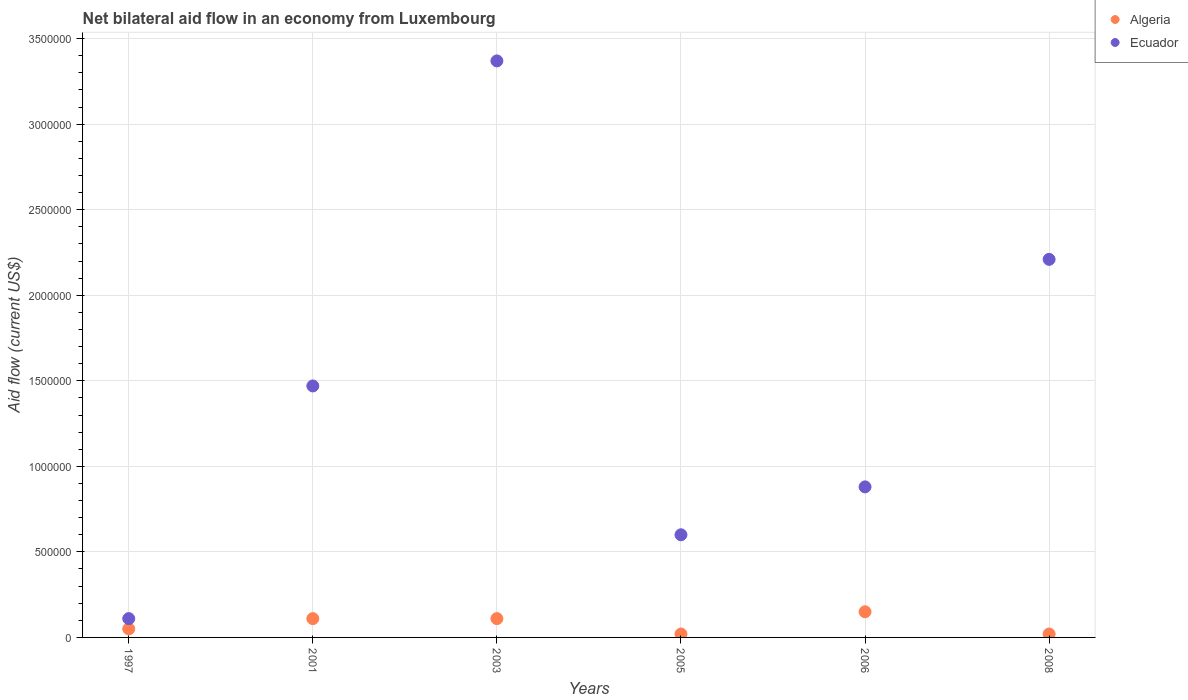How many different coloured dotlines are there?
Ensure brevity in your answer.  2. Across all years, what is the maximum net bilateral aid flow in Ecuador?
Your answer should be very brief. 3.37e+06. In which year was the net bilateral aid flow in Algeria maximum?
Make the answer very short. 2006. What is the total net bilateral aid flow in Algeria in the graph?
Offer a very short reply. 4.60e+05. What is the difference between the net bilateral aid flow in Algeria in 1997 and that in 2003?
Your response must be concise. -6.00e+04. What is the difference between the net bilateral aid flow in Ecuador in 2003 and the net bilateral aid flow in Algeria in 1997?
Offer a terse response. 3.32e+06. What is the average net bilateral aid flow in Ecuador per year?
Give a very brief answer. 1.44e+06. In the year 2005, what is the difference between the net bilateral aid flow in Ecuador and net bilateral aid flow in Algeria?
Make the answer very short. 5.80e+05. What is the ratio of the net bilateral aid flow in Algeria in 2003 to that in 2006?
Provide a short and direct response. 0.73. Is the net bilateral aid flow in Algeria in 2003 less than that in 2005?
Your answer should be very brief. No. Is the difference between the net bilateral aid flow in Ecuador in 2003 and 2005 greater than the difference between the net bilateral aid flow in Algeria in 2003 and 2005?
Give a very brief answer. Yes. What is the difference between the highest and the second highest net bilateral aid flow in Ecuador?
Make the answer very short. 1.16e+06. Is the sum of the net bilateral aid flow in Ecuador in 2003 and 2006 greater than the maximum net bilateral aid flow in Algeria across all years?
Give a very brief answer. Yes. Does the net bilateral aid flow in Algeria monotonically increase over the years?
Your answer should be very brief. No. Is the net bilateral aid flow in Algeria strictly greater than the net bilateral aid flow in Ecuador over the years?
Provide a short and direct response. No. Is the net bilateral aid flow in Ecuador strictly less than the net bilateral aid flow in Algeria over the years?
Your answer should be compact. No. How many years are there in the graph?
Your response must be concise. 6. How are the legend labels stacked?
Your answer should be compact. Vertical. What is the title of the graph?
Provide a succinct answer. Net bilateral aid flow in an economy from Luxembourg. What is the label or title of the Y-axis?
Your answer should be very brief. Aid flow (current US$). What is the Aid flow (current US$) of Ecuador in 1997?
Ensure brevity in your answer.  1.10e+05. What is the Aid flow (current US$) in Algeria in 2001?
Provide a short and direct response. 1.10e+05. What is the Aid flow (current US$) of Ecuador in 2001?
Keep it short and to the point. 1.47e+06. What is the Aid flow (current US$) of Ecuador in 2003?
Provide a succinct answer. 3.37e+06. What is the Aid flow (current US$) in Ecuador in 2005?
Your answer should be very brief. 6.00e+05. What is the Aid flow (current US$) of Ecuador in 2006?
Make the answer very short. 8.80e+05. What is the Aid flow (current US$) of Algeria in 2008?
Keep it short and to the point. 2.00e+04. What is the Aid flow (current US$) of Ecuador in 2008?
Keep it short and to the point. 2.21e+06. Across all years, what is the maximum Aid flow (current US$) of Ecuador?
Your answer should be very brief. 3.37e+06. Across all years, what is the minimum Aid flow (current US$) in Algeria?
Your answer should be compact. 2.00e+04. What is the total Aid flow (current US$) in Algeria in the graph?
Your answer should be very brief. 4.60e+05. What is the total Aid flow (current US$) in Ecuador in the graph?
Offer a very short reply. 8.64e+06. What is the difference between the Aid flow (current US$) in Algeria in 1997 and that in 2001?
Ensure brevity in your answer.  -6.00e+04. What is the difference between the Aid flow (current US$) of Ecuador in 1997 and that in 2001?
Your answer should be compact. -1.36e+06. What is the difference between the Aid flow (current US$) of Algeria in 1997 and that in 2003?
Give a very brief answer. -6.00e+04. What is the difference between the Aid flow (current US$) in Ecuador in 1997 and that in 2003?
Keep it short and to the point. -3.26e+06. What is the difference between the Aid flow (current US$) of Algeria in 1997 and that in 2005?
Your response must be concise. 3.00e+04. What is the difference between the Aid flow (current US$) in Ecuador in 1997 and that in 2005?
Keep it short and to the point. -4.90e+05. What is the difference between the Aid flow (current US$) of Algeria in 1997 and that in 2006?
Provide a short and direct response. -1.00e+05. What is the difference between the Aid flow (current US$) of Ecuador in 1997 and that in 2006?
Provide a succinct answer. -7.70e+05. What is the difference between the Aid flow (current US$) in Algeria in 1997 and that in 2008?
Ensure brevity in your answer.  3.00e+04. What is the difference between the Aid flow (current US$) of Ecuador in 1997 and that in 2008?
Your answer should be compact. -2.10e+06. What is the difference between the Aid flow (current US$) of Algeria in 2001 and that in 2003?
Your answer should be very brief. 0. What is the difference between the Aid flow (current US$) in Ecuador in 2001 and that in 2003?
Your response must be concise. -1.90e+06. What is the difference between the Aid flow (current US$) of Ecuador in 2001 and that in 2005?
Provide a short and direct response. 8.70e+05. What is the difference between the Aid flow (current US$) of Ecuador in 2001 and that in 2006?
Give a very brief answer. 5.90e+05. What is the difference between the Aid flow (current US$) of Ecuador in 2001 and that in 2008?
Provide a succinct answer. -7.40e+05. What is the difference between the Aid flow (current US$) of Ecuador in 2003 and that in 2005?
Offer a very short reply. 2.77e+06. What is the difference between the Aid flow (current US$) in Ecuador in 2003 and that in 2006?
Your answer should be very brief. 2.49e+06. What is the difference between the Aid flow (current US$) of Algeria in 2003 and that in 2008?
Your answer should be compact. 9.00e+04. What is the difference between the Aid flow (current US$) in Ecuador in 2003 and that in 2008?
Offer a very short reply. 1.16e+06. What is the difference between the Aid flow (current US$) in Algeria in 2005 and that in 2006?
Offer a terse response. -1.30e+05. What is the difference between the Aid flow (current US$) of Ecuador in 2005 and that in 2006?
Keep it short and to the point. -2.80e+05. What is the difference between the Aid flow (current US$) in Algeria in 2005 and that in 2008?
Your response must be concise. 0. What is the difference between the Aid flow (current US$) in Ecuador in 2005 and that in 2008?
Make the answer very short. -1.61e+06. What is the difference between the Aid flow (current US$) of Algeria in 2006 and that in 2008?
Your response must be concise. 1.30e+05. What is the difference between the Aid flow (current US$) in Ecuador in 2006 and that in 2008?
Your answer should be very brief. -1.33e+06. What is the difference between the Aid flow (current US$) in Algeria in 1997 and the Aid flow (current US$) in Ecuador in 2001?
Make the answer very short. -1.42e+06. What is the difference between the Aid flow (current US$) of Algeria in 1997 and the Aid flow (current US$) of Ecuador in 2003?
Offer a terse response. -3.32e+06. What is the difference between the Aid flow (current US$) in Algeria in 1997 and the Aid flow (current US$) in Ecuador in 2005?
Keep it short and to the point. -5.50e+05. What is the difference between the Aid flow (current US$) of Algeria in 1997 and the Aid flow (current US$) of Ecuador in 2006?
Offer a very short reply. -8.30e+05. What is the difference between the Aid flow (current US$) in Algeria in 1997 and the Aid flow (current US$) in Ecuador in 2008?
Provide a short and direct response. -2.16e+06. What is the difference between the Aid flow (current US$) of Algeria in 2001 and the Aid flow (current US$) of Ecuador in 2003?
Offer a terse response. -3.26e+06. What is the difference between the Aid flow (current US$) of Algeria in 2001 and the Aid flow (current US$) of Ecuador in 2005?
Offer a very short reply. -4.90e+05. What is the difference between the Aid flow (current US$) in Algeria in 2001 and the Aid flow (current US$) in Ecuador in 2006?
Give a very brief answer. -7.70e+05. What is the difference between the Aid flow (current US$) of Algeria in 2001 and the Aid flow (current US$) of Ecuador in 2008?
Your answer should be compact. -2.10e+06. What is the difference between the Aid flow (current US$) of Algeria in 2003 and the Aid flow (current US$) of Ecuador in 2005?
Your response must be concise. -4.90e+05. What is the difference between the Aid flow (current US$) in Algeria in 2003 and the Aid flow (current US$) in Ecuador in 2006?
Make the answer very short. -7.70e+05. What is the difference between the Aid flow (current US$) of Algeria in 2003 and the Aid flow (current US$) of Ecuador in 2008?
Ensure brevity in your answer.  -2.10e+06. What is the difference between the Aid flow (current US$) in Algeria in 2005 and the Aid flow (current US$) in Ecuador in 2006?
Ensure brevity in your answer.  -8.60e+05. What is the difference between the Aid flow (current US$) in Algeria in 2005 and the Aid flow (current US$) in Ecuador in 2008?
Ensure brevity in your answer.  -2.19e+06. What is the difference between the Aid flow (current US$) in Algeria in 2006 and the Aid flow (current US$) in Ecuador in 2008?
Your answer should be compact. -2.06e+06. What is the average Aid flow (current US$) in Algeria per year?
Ensure brevity in your answer.  7.67e+04. What is the average Aid flow (current US$) of Ecuador per year?
Offer a terse response. 1.44e+06. In the year 2001, what is the difference between the Aid flow (current US$) of Algeria and Aid flow (current US$) of Ecuador?
Provide a succinct answer. -1.36e+06. In the year 2003, what is the difference between the Aid flow (current US$) in Algeria and Aid flow (current US$) in Ecuador?
Keep it short and to the point. -3.26e+06. In the year 2005, what is the difference between the Aid flow (current US$) in Algeria and Aid flow (current US$) in Ecuador?
Ensure brevity in your answer.  -5.80e+05. In the year 2006, what is the difference between the Aid flow (current US$) of Algeria and Aid flow (current US$) of Ecuador?
Your answer should be very brief. -7.30e+05. In the year 2008, what is the difference between the Aid flow (current US$) of Algeria and Aid flow (current US$) of Ecuador?
Make the answer very short. -2.19e+06. What is the ratio of the Aid flow (current US$) of Algeria in 1997 to that in 2001?
Make the answer very short. 0.45. What is the ratio of the Aid flow (current US$) of Ecuador in 1997 to that in 2001?
Give a very brief answer. 0.07. What is the ratio of the Aid flow (current US$) in Algeria in 1997 to that in 2003?
Your answer should be very brief. 0.45. What is the ratio of the Aid flow (current US$) in Ecuador in 1997 to that in 2003?
Provide a short and direct response. 0.03. What is the ratio of the Aid flow (current US$) in Ecuador in 1997 to that in 2005?
Your answer should be very brief. 0.18. What is the ratio of the Aid flow (current US$) in Algeria in 1997 to that in 2006?
Your response must be concise. 0.33. What is the ratio of the Aid flow (current US$) of Ecuador in 1997 to that in 2008?
Ensure brevity in your answer.  0.05. What is the ratio of the Aid flow (current US$) of Ecuador in 2001 to that in 2003?
Give a very brief answer. 0.44. What is the ratio of the Aid flow (current US$) in Algeria in 2001 to that in 2005?
Offer a terse response. 5.5. What is the ratio of the Aid flow (current US$) of Ecuador in 2001 to that in 2005?
Your response must be concise. 2.45. What is the ratio of the Aid flow (current US$) in Algeria in 2001 to that in 2006?
Provide a short and direct response. 0.73. What is the ratio of the Aid flow (current US$) of Ecuador in 2001 to that in 2006?
Offer a terse response. 1.67. What is the ratio of the Aid flow (current US$) in Ecuador in 2001 to that in 2008?
Your response must be concise. 0.67. What is the ratio of the Aid flow (current US$) of Ecuador in 2003 to that in 2005?
Provide a succinct answer. 5.62. What is the ratio of the Aid flow (current US$) of Algeria in 2003 to that in 2006?
Provide a short and direct response. 0.73. What is the ratio of the Aid flow (current US$) of Ecuador in 2003 to that in 2006?
Make the answer very short. 3.83. What is the ratio of the Aid flow (current US$) in Ecuador in 2003 to that in 2008?
Keep it short and to the point. 1.52. What is the ratio of the Aid flow (current US$) in Algeria in 2005 to that in 2006?
Your answer should be compact. 0.13. What is the ratio of the Aid flow (current US$) of Ecuador in 2005 to that in 2006?
Keep it short and to the point. 0.68. What is the ratio of the Aid flow (current US$) in Ecuador in 2005 to that in 2008?
Provide a short and direct response. 0.27. What is the ratio of the Aid flow (current US$) in Ecuador in 2006 to that in 2008?
Offer a terse response. 0.4. What is the difference between the highest and the second highest Aid flow (current US$) of Ecuador?
Make the answer very short. 1.16e+06. What is the difference between the highest and the lowest Aid flow (current US$) of Ecuador?
Give a very brief answer. 3.26e+06. 